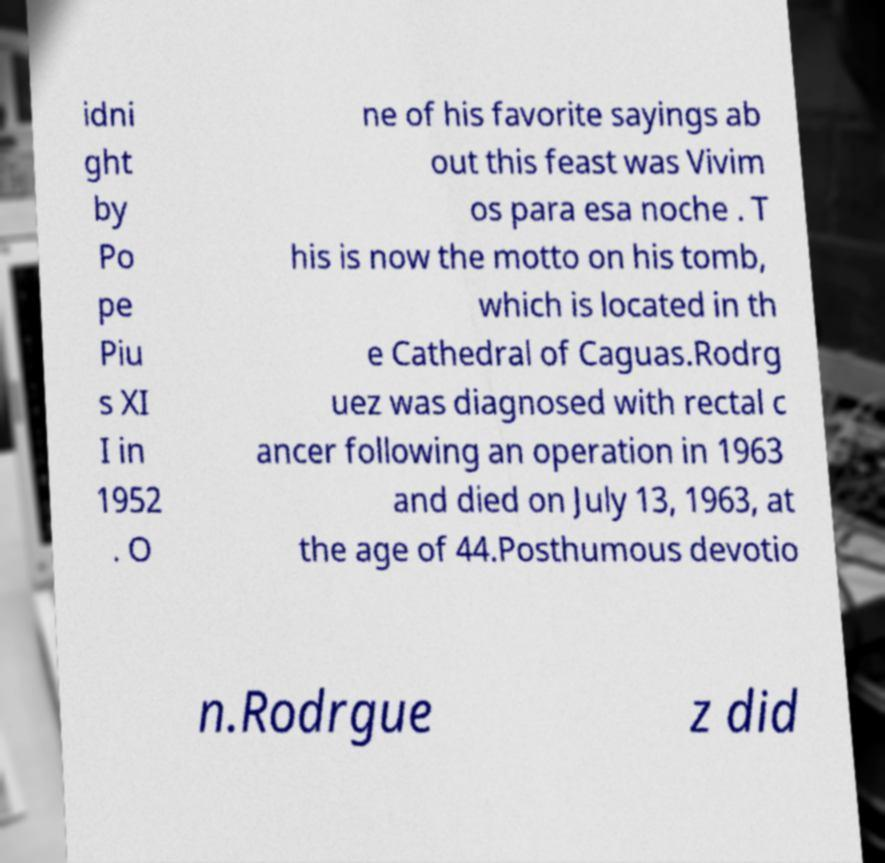Could you assist in decoding the text presented in this image and type it out clearly? idni ght by Po pe Piu s XI I in 1952 . O ne of his favorite sayings ab out this feast was Vivim os para esa noche . T his is now the motto on his tomb, which is located in th e Cathedral of Caguas.Rodrg uez was diagnosed with rectal c ancer following an operation in 1963 and died on July 13, 1963, at the age of 44.Posthumous devotio n.Rodrgue z did 